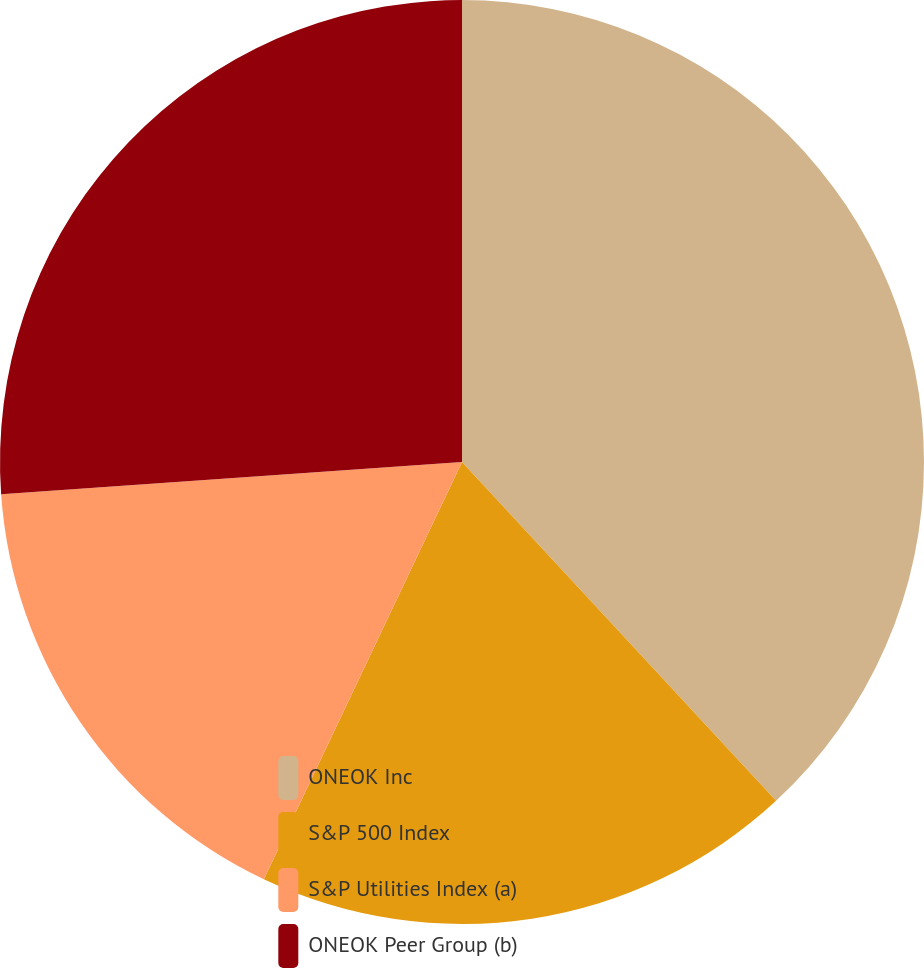<chart> <loc_0><loc_0><loc_500><loc_500><pie_chart><fcel>ONEOK Inc<fcel>S&P 500 Index<fcel>S&P Utilities Index (a)<fcel>ONEOK Peer Group (b)<nl><fcel>38.1%<fcel>18.95%<fcel>16.83%<fcel>26.11%<nl></chart> 